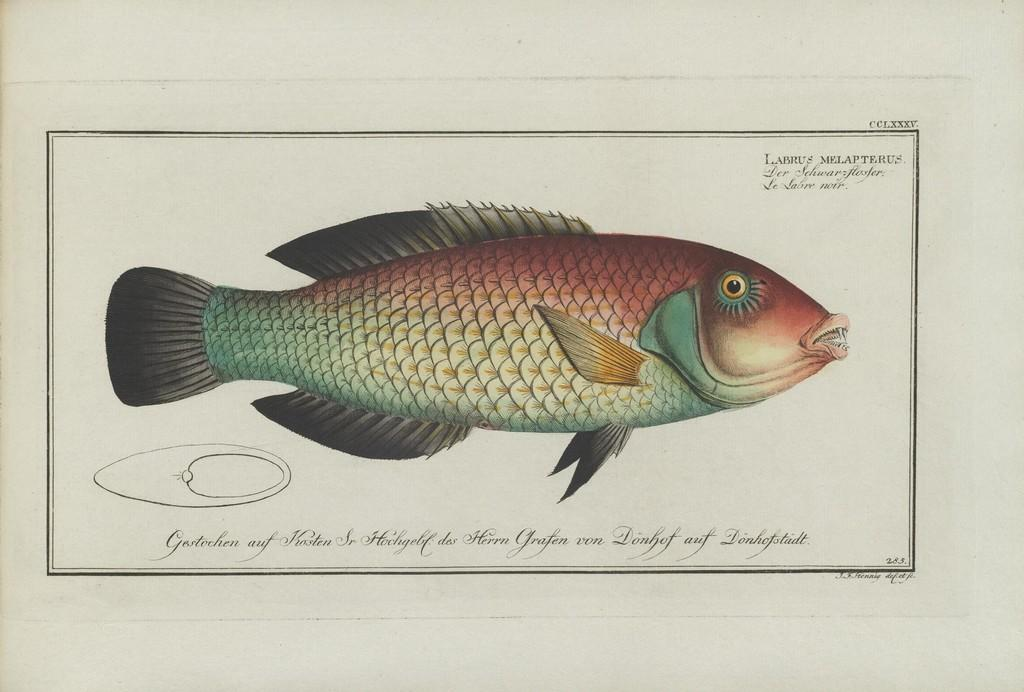What is present on the paper in the image? The paper has words, numbers, and an image of a fish on it. Where is the paper located in the image? The paper is on an object. What type of content can be found on the paper? The paper contains words and numbers. What type of rose is depicted in the image? There is no rose present in the image; it features a paper with words, numbers, and an image of a fish. 